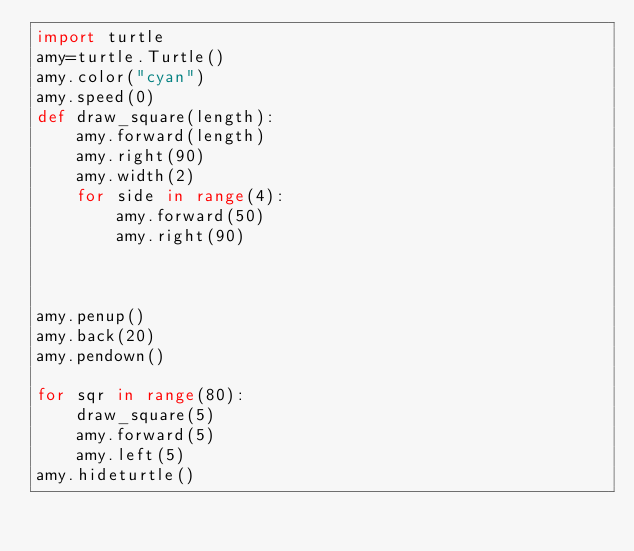Convert code to text. <code><loc_0><loc_0><loc_500><loc_500><_Python_>import turtle
amy=turtle.Turtle()
amy.color("cyan")
amy.speed(0)
def draw_square(length):
    amy.forward(length)
    amy.right(90)
    amy.width(2)
    for side in range(4):
        amy.forward(50)
        amy.right(90)



amy.penup()
amy.back(20)
amy.pendown()

for sqr in range(80):
    draw_square(5)
    amy.forward(5)
    amy.left(5)
amy.hideturtle()
</code> 